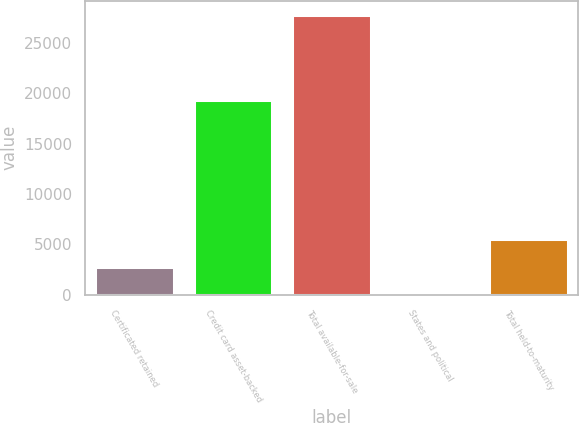<chart> <loc_0><loc_0><loc_500><loc_500><bar_chart><fcel>Certificated retained<fcel>Credit card asset-backed<fcel>Total available-for-sale<fcel>States and political<fcel>Total held-to-maturity<nl><fcel>2796.6<fcel>19362<fcel>27795<fcel>19<fcel>5574.2<nl></chart> 